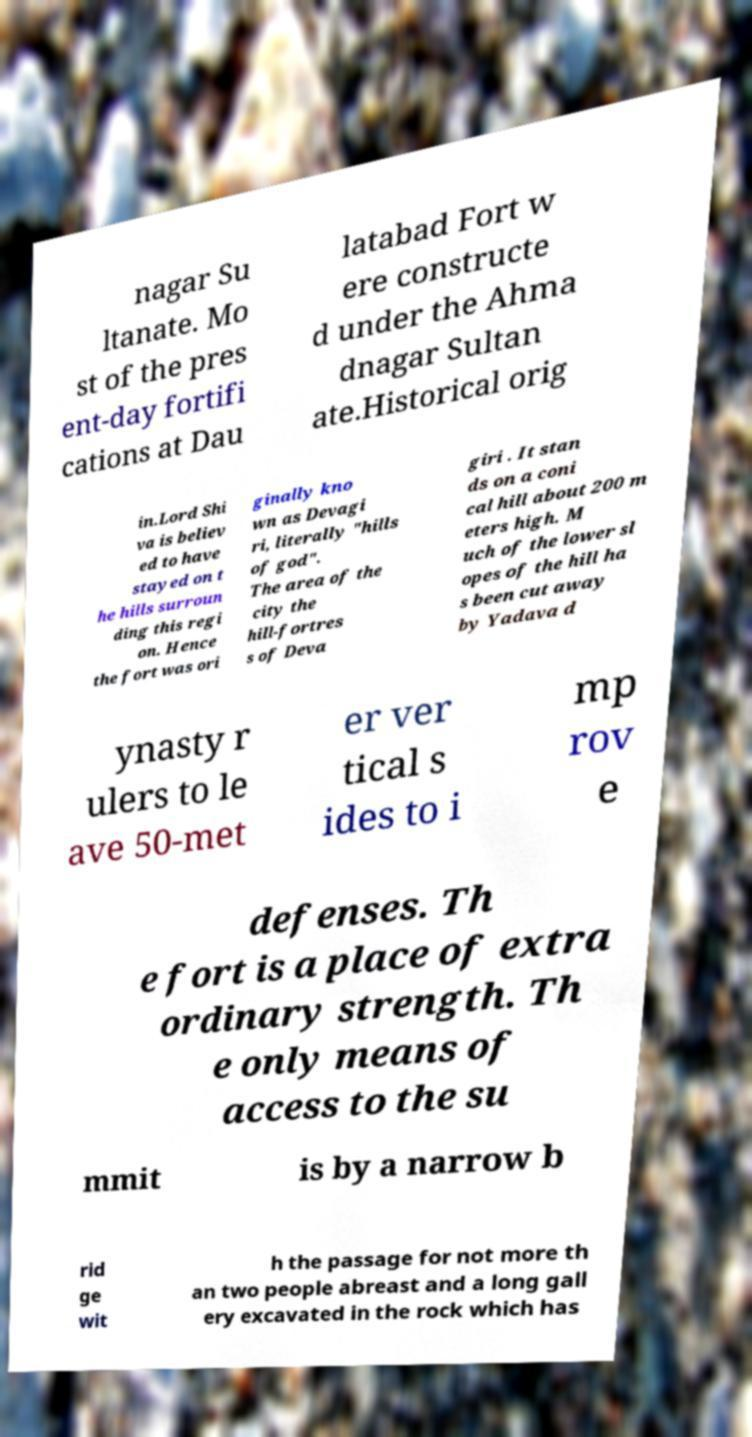I need the written content from this picture converted into text. Can you do that? nagar Su ltanate. Mo st of the pres ent-day fortifi cations at Dau latabad Fort w ere constructe d under the Ahma dnagar Sultan ate.Historical orig in.Lord Shi va is believ ed to have stayed on t he hills surroun ding this regi on. Hence the fort was ori ginally kno wn as Devagi ri, literally "hills of god". The area of the city the hill-fortres s of Deva giri . It stan ds on a coni cal hill about 200 m eters high. M uch of the lower sl opes of the hill ha s been cut away by Yadava d ynasty r ulers to le ave 50-met er ver tical s ides to i mp rov e defenses. Th e fort is a place of extra ordinary strength. Th e only means of access to the su mmit is by a narrow b rid ge wit h the passage for not more th an two people abreast and a long gall ery excavated in the rock which has 